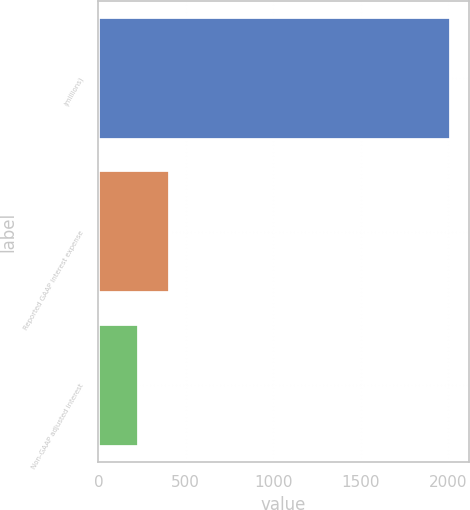<chart> <loc_0><loc_0><loc_500><loc_500><bar_chart><fcel>(millions)<fcel>Reported GAAP interest expense<fcel>Non-GAAP adjusted interest<nl><fcel>2017<fcel>411.49<fcel>233.1<nl></chart> 